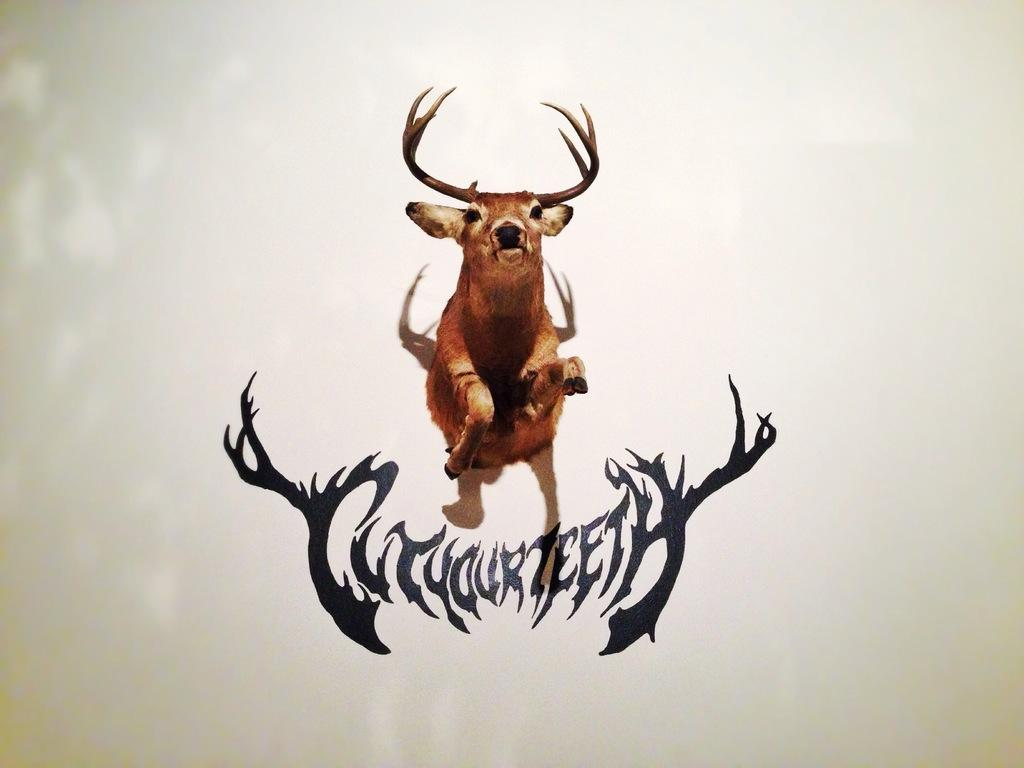What animal can be seen in the image? There is a deer in the image. What is the deer doing in the image? The deer is in a jumping position. Are there any words or letters in the image? Yes, there is text in the image. What color is the background of the image? The background of the image is white. Where is the nest located in the image? There is no nest present in the image. What type of army is depicted in the image? There is no army depicted in the image; it features a deer in a jumping position. 